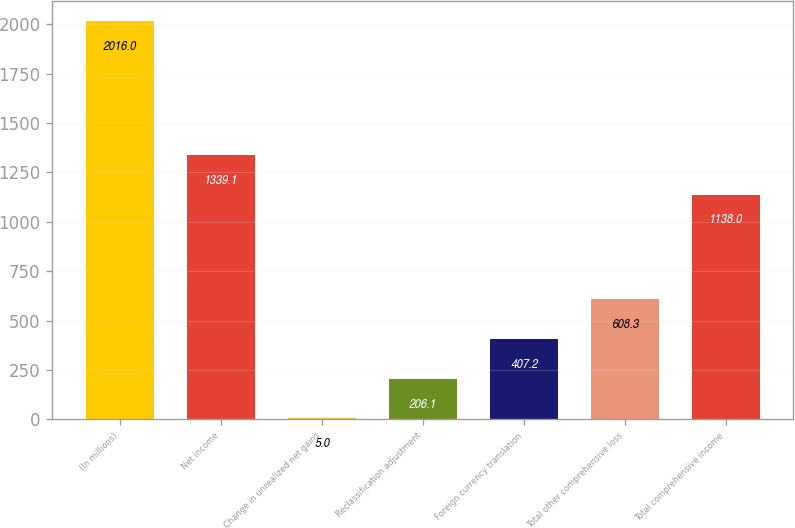Convert chart to OTSL. <chart><loc_0><loc_0><loc_500><loc_500><bar_chart><fcel>(In millions)<fcel>Net income<fcel>Change in unrealized net gains<fcel>Reclassification adjustment<fcel>Foreign currency translation<fcel>Total other comprehensive loss<fcel>Total comprehensive income<nl><fcel>2016<fcel>1339.1<fcel>5<fcel>206.1<fcel>407.2<fcel>608.3<fcel>1138<nl></chart> 